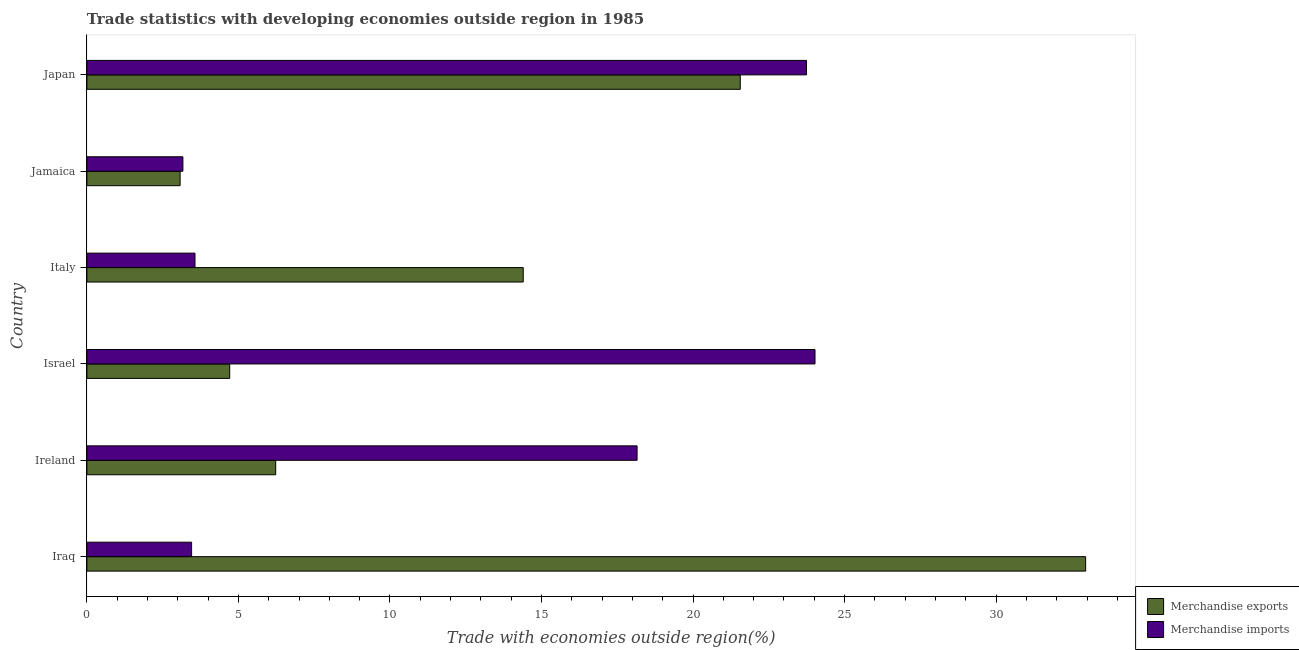How many different coloured bars are there?
Provide a short and direct response. 2. How many groups of bars are there?
Your response must be concise. 6. Are the number of bars per tick equal to the number of legend labels?
Your answer should be compact. Yes. Are the number of bars on each tick of the Y-axis equal?
Provide a succinct answer. Yes. How many bars are there on the 2nd tick from the top?
Your response must be concise. 2. How many bars are there on the 3rd tick from the bottom?
Your response must be concise. 2. What is the label of the 6th group of bars from the top?
Ensure brevity in your answer.  Iraq. In how many cases, is the number of bars for a given country not equal to the number of legend labels?
Provide a succinct answer. 0. What is the merchandise exports in Japan?
Your answer should be compact. 21.56. Across all countries, what is the maximum merchandise exports?
Ensure brevity in your answer.  32.95. Across all countries, what is the minimum merchandise exports?
Provide a succinct answer. 3.08. In which country was the merchandise exports maximum?
Your answer should be compact. Iraq. In which country was the merchandise exports minimum?
Your answer should be compact. Jamaica. What is the total merchandise exports in the graph?
Provide a short and direct response. 82.93. What is the difference between the merchandise imports in Israel and that in Italy?
Offer a very short reply. 20.46. What is the difference between the merchandise exports in Japan and the merchandise imports in Israel?
Provide a succinct answer. -2.47. What is the average merchandise imports per country?
Provide a short and direct response. 12.69. What is the difference between the merchandise imports and merchandise exports in Jamaica?
Offer a very short reply. 0.09. In how many countries, is the merchandise imports greater than 5 %?
Your answer should be very brief. 3. What is the ratio of the merchandise imports in Iraq to that in Ireland?
Offer a very short reply. 0.19. Is the merchandise exports in Italy less than that in Jamaica?
Provide a short and direct response. No. What is the difference between the highest and the second highest merchandise imports?
Provide a succinct answer. 0.28. What is the difference between the highest and the lowest merchandise imports?
Offer a very short reply. 20.86. Is the sum of the merchandise imports in Iraq and Jamaica greater than the maximum merchandise exports across all countries?
Offer a terse response. No. What does the 1st bar from the top in Ireland represents?
Offer a terse response. Merchandise imports. What does the 2nd bar from the bottom in Japan represents?
Keep it short and to the point. Merchandise imports. How many bars are there?
Provide a succinct answer. 12. Are all the bars in the graph horizontal?
Offer a terse response. Yes. What is the difference between two consecutive major ticks on the X-axis?
Offer a very short reply. 5. Are the values on the major ticks of X-axis written in scientific E-notation?
Your answer should be compact. No. Where does the legend appear in the graph?
Keep it short and to the point. Bottom right. How are the legend labels stacked?
Offer a terse response. Vertical. What is the title of the graph?
Offer a very short reply. Trade statistics with developing economies outside region in 1985. Does "Urban Population" appear as one of the legend labels in the graph?
Your response must be concise. No. What is the label or title of the X-axis?
Offer a very short reply. Trade with economies outside region(%). What is the label or title of the Y-axis?
Ensure brevity in your answer.  Country. What is the Trade with economies outside region(%) of Merchandise exports in Iraq?
Give a very brief answer. 32.95. What is the Trade with economies outside region(%) in Merchandise imports in Iraq?
Offer a terse response. 3.46. What is the Trade with economies outside region(%) in Merchandise exports in Ireland?
Offer a very short reply. 6.23. What is the Trade with economies outside region(%) of Merchandise imports in Ireland?
Offer a very short reply. 18.15. What is the Trade with economies outside region(%) of Merchandise exports in Israel?
Ensure brevity in your answer.  4.71. What is the Trade with economies outside region(%) of Merchandise imports in Israel?
Your answer should be very brief. 24.02. What is the Trade with economies outside region(%) in Merchandise exports in Italy?
Keep it short and to the point. 14.4. What is the Trade with economies outside region(%) of Merchandise imports in Italy?
Ensure brevity in your answer.  3.57. What is the Trade with economies outside region(%) in Merchandise exports in Jamaica?
Keep it short and to the point. 3.08. What is the Trade with economies outside region(%) in Merchandise imports in Jamaica?
Your answer should be very brief. 3.17. What is the Trade with economies outside region(%) in Merchandise exports in Japan?
Make the answer very short. 21.56. What is the Trade with economies outside region(%) in Merchandise imports in Japan?
Your answer should be very brief. 23.74. Across all countries, what is the maximum Trade with economies outside region(%) of Merchandise exports?
Make the answer very short. 32.95. Across all countries, what is the maximum Trade with economies outside region(%) of Merchandise imports?
Give a very brief answer. 24.02. Across all countries, what is the minimum Trade with economies outside region(%) of Merchandise exports?
Give a very brief answer. 3.08. Across all countries, what is the minimum Trade with economies outside region(%) of Merchandise imports?
Keep it short and to the point. 3.17. What is the total Trade with economies outside region(%) in Merchandise exports in the graph?
Make the answer very short. 82.93. What is the total Trade with economies outside region(%) in Merchandise imports in the graph?
Your answer should be very brief. 76.11. What is the difference between the Trade with economies outside region(%) of Merchandise exports in Iraq and that in Ireland?
Ensure brevity in your answer.  26.72. What is the difference between the Trade with economies outside region(%) in Merchandise imports in Iraq and that in Ireland?
Offer a very short reply. -14.7. What is the difference between the Trade with economies outside region(%) of Merchandise exports in Iraq and that in Israel?
Your answer should be very brief. 28.24. What is the difference between the Trade with economies outside region(%) of Merchandise imports in Iraq and that in Israel?
Offer a very short reply. -20.57. What is the difference between the Trade with economies outside region(%) in Merchandise exports in Iraq and that in Italy?
Offer a terse response. 18.56. What is the difference between the Trade with economies outside region(%) of Merchandise imports in Iraq and that in Italy?
Provide a succinct answer. -0.11. What is the difference between the Trade with economies outside region(%) in Merchandise exports in Iraq and that in Jamaica?
Your response must be concise. 29.88. What is the difference between the Trade with economies outside region(%) of Merchandise imports in Iraq and that in Jamaica?
Make the answer very short. 0.29. What is the difference between the Trade with economies outside region(%) of Merchandise exports in Iraq and that in Japan?
Offer a terse response. 11.4. What is the difference between the Trade with economies outside region(%) in Merchandise imports in Iraq and that in Japan?
Your answer should be compact. -20.29. What is the difference between the Trade with economies outside region(%) in Merchandise exports in Ireland and that in Israel?
Give a very brief answer. 1.52. What is the difference between the Trade with economies outside region(%) in Merchandise imports in Ireland and that in Israel?
Your answer should be very brief. -5.87. What is the difference between the Trade with economies outside region(%) in Merchandise exports in Ireland and that in Italy?
Make the answer very short. -8.17. What is the difference between the Trade with economies outside region(%) of Merchandise imports in Ireland and that in Italy?
Your answer should be very brief. 14.59. What is the difference between the Trade with economies outside region(%) in Merchandise exports in Ireland and that in Jamaica?
Your answer should be compact. 3.15. What is the difference between the Trade with economies outside region(%) in Merchandise imports in Ireland and that in Jamaica?
Keep it short and to the point. 14.99. What is the difference between the Trade with economies outside region(%) of Merchandise exports in Ireland and that in Japan?
Make the answer very short. -15.33. What is the difference between the Trade with economies outside region(%) in Merchandise imports in Ireland and that in Japan?
Provide a short and direct response. -5.59. What is the difference between the Trade with economies outside region(%) in Merchandise exports in Israel and that in Italy?
Your answer should be compact. -9.69. What is the difference between the Trade with economies outside region(%) of Merchandise imports in Israel and that in Italy?
Give a very brief answer. 20.46. What is the difference between the Trade with economies outside region(%) of Merchandise exports in Israel and that in Jamaica?
Provide a short and direct response. 1.64. What is the difference between the Trade with economies outside region(%) in Merchandise imports in Israel and that in Jamaica?
Give a very brief answer. 20.86. What is the difference between the Trade with economies outside region(%) in Merchandise exports in Israel and that in Japan?
Keep it short and to the point. -16.85. What is the difference between the Trade with economies outside region(%) of Merchandise imports in Israel and that in Japan?
Offer a terse response. 0.28. What is the difference between the Trade with economies outside region(%) in Merchandise exports in Italy and that in Jamaica?
Your response must be concise. 11.32. What is the difference between the Trade with economies outside region(%) in Merchandise imports in Italy and that in Jamaica?
Ensure brevity in your answer.  0.4. What is the difference between the Trade with economies outside region(%) in Merchandise exports in Italy and that in Japan?
Ensure brevity in your answer.  -7.16. What is the difference between the Trade with economies outside region(%) of Merchandise imports in Italy and that in Japan?
Ensure brevity in your answer.  -20.18. What is the difference between the Trade with economies outside region(%) in Merchandise exports in Jamaica and that in Japan?
Make the answer very short. -18.48. What is the difference between the Trade with economies outside region(%) of Merchandise imports in Jamaica and that in Japan?
Give a very brief answer. -20.58. What is the difference between the Trade with economies outside region(%) in Merchandise exports in Iraq and the Trade with economies outside region(%) in Merchandise imports in Ireland?
Offer a very short reply. 14.8. What is the difference between the Trade with economies outside region(%) of Merchandise exports in Iraq and the Trade with economies outside region(%) of Merchandise imports in Israel?
Keep it short and to the point. 8.93. What is the difference between the Trade with economies outside region(%) in Merchandise exports in Iraq and the Trade with economies outside region(%) in Merchandise imports in Italy?
Make the answer very short. 29.39. What is the difference between the Trade with economies outside region(%) in Merchandise exports in Iraq and the Trade with economies outside region(%) in Merchandise imports in Jamaica?
Provide a short and direct response. 29.79. What is the difference between the Trade with economies outside region(%) in Merchandise exports in Iraq and the Trade with economies outside region(%) in Merchandise imports in Japan?
Your answer should be compact. 9.21. What is the difference between the Trade with economies outside region(%) in Merchandise exports in Ireland and the Trade with economies outside region(%) in Merchandise imports in Israel?
Provide a short and direct response. -17.79. What is the difference between the Trade with economies outside region(%) in Merchandise exports in Ireland and the Trade with economies outside region(%) in Merchandise imports in Italy?
Ensure brevity in your answer.  2.66. What is the difference between the Trade with economies outside region(%) of Merchandise exports in Ireland and the Trade with economies outside region(%) of Merchandise imports in Jamaica?
Provide a succinct answer. 3.06. What is the difference between the Trade with economies outside region(%) of Merchandise exports in Ireland and the Trade with economies outside region(%) of Merchandise imports in Japan?
Provide a succinct answer. -17.51. What is the difference between the Trade with economies outside region(%) in Merchandise exports in Israel and the Trade with economies outside region(%) in Merchandise imports in Italy?
Keep it short and to the point. 1.14. What is the difference between the Trade with economies outside region(%) in Merchandise exports in Israel and the Trade with economies outside region(%) in Merchandise imports in Jamaica?
Your answer should be compact. 1.54. What is the difference between the Trade with economies outside region(%) of Merchandise exports in Israel and the Trade with economies outside region(%) of Merchandise imports in Japan?
Provide a short and direct response. -19.03. What is the difference between the Trade with economies outside region(%) of Merchandise exports in Italy and the Trade with economies outside region(%) of Merchandise imports in Jamaica?
Provide a succinct answer. 11.23. What is the difference between the Trade with economies outside region(%) of Merchandise exports in Italy and the Trade with economies outside region(%) of Merchandise imports in Japan?
Your answer should be very brief. -9.35. What is the difference between the Trade with economies outside region(%) in Merchandise exports in Jamaica and the Trade with economies outside region(%) in Merchandise imports in Japan?
Offer a very short reply. -20.67. What is the average Trade with economies outside region(%) in Merchandise exports per country?
Make the answer very short. 13.82. What is the average Trade with economies outside region(%) of Merchandise imports per country?
Ensure brevity in your answer.  12.69. What is the difference between the Trade with economies outside region(%) in Merchandise exports and Trade with economies outside region(%) in Merchandise imports in Iraq?
Provide a succinct answer. 29.5. What is the difference between the Trade with economies outside region(%) in Merchandise exports and Trade with economies outside region(%) in Merchandise imports in Ireland?
Make the answer very short. -11.92. What is the difference between the Trade with economies outside region(%) of Merchandise exports and Trade with economies outside region(%) of Merchandise imports in Israel?
Keep it short and to the point. -19.31. What is the difference between the Trade with economies outside region(%) of Merchandise exports and Trade with economies outside region(%) of Merchandise imports in Italy?
Provide a short and direct response. 10.83. What is the difference between the Trade with economies outside region(%) of Merchandise exports and Trade with economies outside region(%) of Merchandise imports in Jamaica?
Your answer should be very brief. -0.09. What is the difference between the Trade with economies outside region(%) of Merchandise exports and Trade with economies outside region(%) of Merchandise imports in Japan?
Ensure brevity in your answer.  -2.19. What is the ratio of the Trade with economies outside region(%) of Merchandise exports in Iraq to that in Ireland?
Your answer should be compact. 5.29. What is the ratio of the Trade with economies outside region(%) of Merchandise imports in Iraq to that in Ireland?
Offer a very short reply. 0.19. What is the ratio of the Trade with economies outside region(%) in Merchandise exports in Iraq to that in Israel?
Make the answer very short. 6.99. What is the ratio of the Trade with economies outside region(%) of Merchandise imports in Iraq to that in Israel?
Offer a very short reply. 0.14. What is the ratio of the Trade with economies outside region(%) in Merchandise exports in Iraq to that in Italy?
Your answer should be very brief. 2.29. What is the ratio of the Trade with economies outside region(%) of Merchandise imports in Iraq to that in Italy?
Ensure brevity in your answer.  0.97. What is the ratio of the Trade with economies outside region(%) of Merchandise exports in Iraq to that in Jamaica?
Provide a succinct answer. 10.72. What is the ratio of the Trade with economies outside region(%) of Merchandise imports in Iraq to that in Jamaica?
Provide a short and direct response. 1.09. What is the ratio of the Trade with economies outside region(%) in Merchandise exports in Iraq to that in Japan?
Keep it short and to the point. 1.53. What is the ratio of the Trade with economies outside region(%) in Merchandise imports in Iraq to that in Japan?
Offer a very short reply. 0.15. What is the ratio of the Trade with economies outside region(%) in Merchandise exports in Ireland to that in Israel?
Your answer should be very brief. 1.32. What is the ratio of the Trade with economies outside region(%) in Merchandise imports in Ireland to that in Israel?
Ensure brevity in your answer.  0.76. What is the ratio of the Trade with economies outside region(%) of Merchandise exports in Ireland to that in Italy?
Give a very brief answer. 0.43. What is the ratio of the Trade with economies outside region(%) of Merchandise imports in Ireland to that in Italy?
Make the answer very short. 5.09. What is the ratio of the Trade with economies outside region(%) in Merchandise exports in Ireland to that in Jamaica?
Provide a short and direct response. 2.03. What is the ratio of the Trade with economies outside region(%) of Merchandise imports in Ireland to that in Jamaica?
Your response must be concise. 5.73. What is the ratio of the Trade with economies outside region(%) of Merchandise exports in Ireland to that in Japan?
Your answer should be very brief. 0.29. What is the ratio of the Trade with economies outside region(%) of Merchandise imports in Ireland to that in Japan?
Make the answer very short. 0.76. What is the ratio of the Trade with economies outside region(%) in Merchandise exports in Israel to that in Italy?
Offer a terse response. 0.33. What is the ratio of the Trade with economies outside region(%) in Merchandise imports in Israel to that in Italy?
Your answer should be compact. 6.74. What is the ratio of the Trade with economies outside region(%) in Merchandise exports in Israel to that in Jamaica?
Make the answer very short. 1.53. What is the ratio of the Trade with economies outside region(%) of Merchandise imports in Israel to that in Jamaica?
Keep it short and to the point. 7.58. What is the ratio of the Trade with economies outside region(%) of Merchandise exports in Israel to that in Japan?
Your answer should be very brief. 0.22. What is the ratio of the Trade with economies outside region(%) of Merchandise imports in Israel to that in Japan?
Make the answer very short. 1.01. What is the ratio of the Trade with economies outside region(%) of Merchandise exports in Italy to that in Jamaica?
Offer a very short reply. 4.68. What is the ratio of the Trade with economies outside region(%) of Merchandise imports in Italy to that in Jamaica?
Provide a short and direct response. 1.13. What is the ratio of the Trade with economies outside region(%) of Merchandise exports in Italy to that in Japan?
Your response must be concise. 0.67. What is the ratio of the Trade with economies outside region(%) of Merchandise imports in Italy to that in Japan?
Your answer should be very brief. 0.15. What is the ratio of the Trade with economies outside region(%) in Merchandise exports in Jamaica to that in Japan?
Provide a succinct answer. 0.14. What is the ratio of the Trade with economies outside region(%) of Merchandise imports in Jamaica to that in Japan?
Offer a very short reply. 0.13. What is the difference between the highest and the second highest Trade with economies outside region(%) in Merchandise exports?
Keep it short and to the point. 11.4. What is the difference between the highest and the second highest Trade with economies outside region(%) in Merchandise imports?
Make the answer very short. 0.28. What is the difference between the highest and the lowest Trade with economies outside region(%) of Merchandise exports?
Ensure brevity in your answer.  29.88. What is the difference between the highest and the lowest Trade with economies outside region(%) in Merchandise imports?
Your response must be concise. 20.86. 